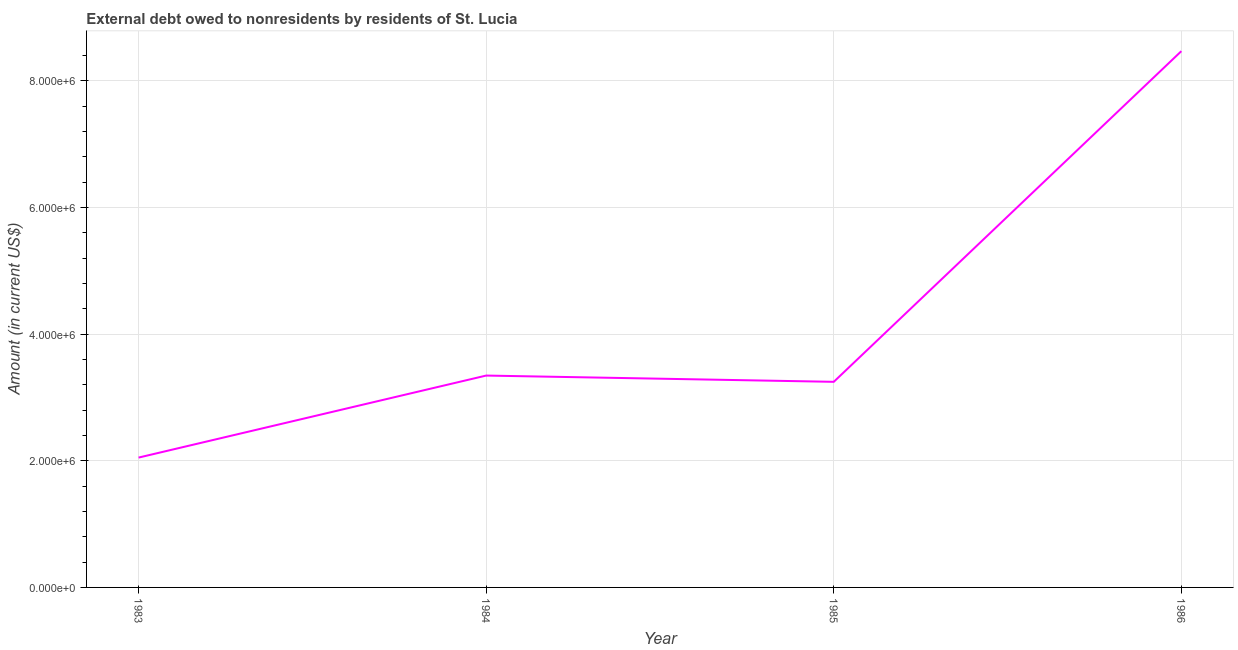What is the debt in 1983?
Ensure brevity in your answer.  2.05e+06. Across all years, what is the maximum debt?
Ensure brevity in your answer.  8.47e+06. Across all years, what is the minimum debt?
Ensure brevity in your answer.  2.05e+06. In which year was the debt maximum?
Offer a very short reply. 1986. In which year was the debt minimum?
Ensure brevity in your answer.  1983. What is the sum of the debt?
Provide a short and direct response. 1.71e+07. What is the difference between the debt in 1984 and 1985?
Provide a succinct answer. 9.90e+04. What is the average debt per year?
Ensure brevity in your answer.  4.28e+06. What is the median debt?
Your answer should be compact. 3.30e+06. Do a majority of the years between 1983 and 1984 (inclusive) have debt greater than 2400000 US$?
Give a very brief answer. No. What is the ratio of the debt in 1985 to that in 1986?
Provide a short and direct response. 0.38. Is the difference between the debt in 1983 and 1985 greater than the difference between any two years?
Your response must be concise. No. What is the difference between the highest and the second highest debt?
Your answer should be very brief. 5.12e+06. Is the sum of the debt in 1985 and 1986 greater than the maximum debt across all years?
Provide a succinct answer. Yes. What is the difference between the highest and the lowest debt?
Provide a short and direct response. 6.42e+06. What is the difference between two consecutive major ticks on the Y-axis?
Provide a succinct answer. 2.00e+06. Does the graph contain any zero values?
Keep it short and to the point. No. Does the graph contain grids?
Offer a terse response. Yes. What is the title of the graph?
Your response must be concise. External debt owed to nonresidents by residents of St. Lucia. What is the label or title of the Y-axis?
Provide a succinct answer. Amount (in current US$). What is the Amount (in current US$) in 1983?
Provide a succinct answer. 2.05e+06. What is the Amount (in current US$) in 1984?
Provide a succinct answer. 3.34e+06. What is the Amount (in current US$) in 1985?
Offer a very short reply. 3.25e+06. What is the Amount (in current US$) of 1986?
Ensure brevity in your answer.  8.47e+06. What is the difference between the Amount (in current US$) in 1983 and 1984?
Make the answer very short. -1.30e+06. What is the difference between the Amount (in current US$) in 1983 and 1985?
Offer a very short reply. -1.20e+06. What is the difference between the Amount (in current US$) in 1983 and 1986?
Keep it short and to the point. -6.42e+06. What is the difference between the Amount (in current US$) in 1984 and 1985?
Offer a very short reply. 9.90e+04. What is the difference between the Amount (in current US$) in 1984 and 1986?
Ensure brevity in your answer.  -5.12e+06. What is the difference between the Amount (in current US$) in 1985 and 1986?
Offer a very short reply. -5.22e+06. What is the ratio of the Amount (in current US$) in 1983 to that in 1984?
Your response must be concise. 0.61. What is the ratio of the Amount (in current US$) in 1983 to that in 1985?
Provide a short and direct response. 0.63. What is the ratio of the Amount (in current US$) in 1983 to that in 1986?
Give a very brief answer. 0.24. What is the ratio of the Amount (in current US$) in 1984 to that in 1985?
Provide a succinct answer. 1.03. What is the ratio of the Amount (in current US$) in 1984 to that in 1986?
Ensure brevity in your answer.  0.4. What is the ratio of the Amount (in current US$) in 1985 to that in 1986?
Make the answer very short. 0.38. 